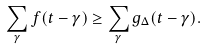Convert formula to latex. <formula><loc_0><loc_0><loc_500><loc_500>\sum _ { \gamma } f ( t - \gamma ) \geq \sum _ { \gamma } g _ { \Delta } ( t - \gamma ) .</formula> 